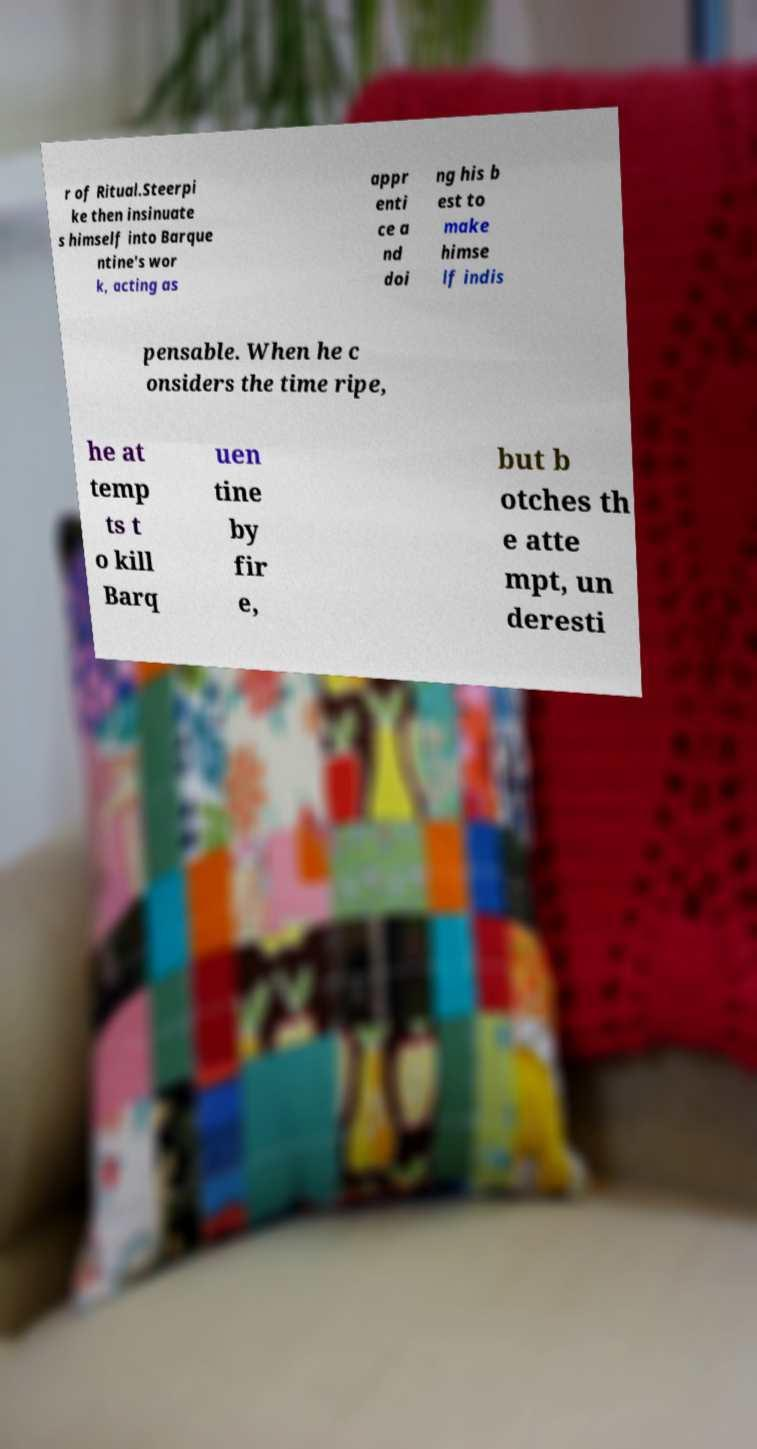Please read and relay the text visible in this image. What does it say? r of Ritual.Steerpi ke then insinuate s himself into Barque ntine's wor k, acting as appr enti ce a nd doi ng his b est to make himse lf indis pensable. When he c onsiders the time ripe, he at temp ts t o kill Barq uen tine by fir e, but b otches th e atte mpt, un deresti 